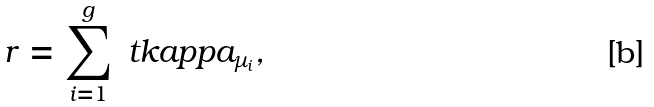Convert formula to latex. <formula><loc_0><loc_0><loc_500><loc_500>r = \sum _ { i = 1 } ^ { g } \ t k a p p a _ { \mu _ { i } } ,</formula> 